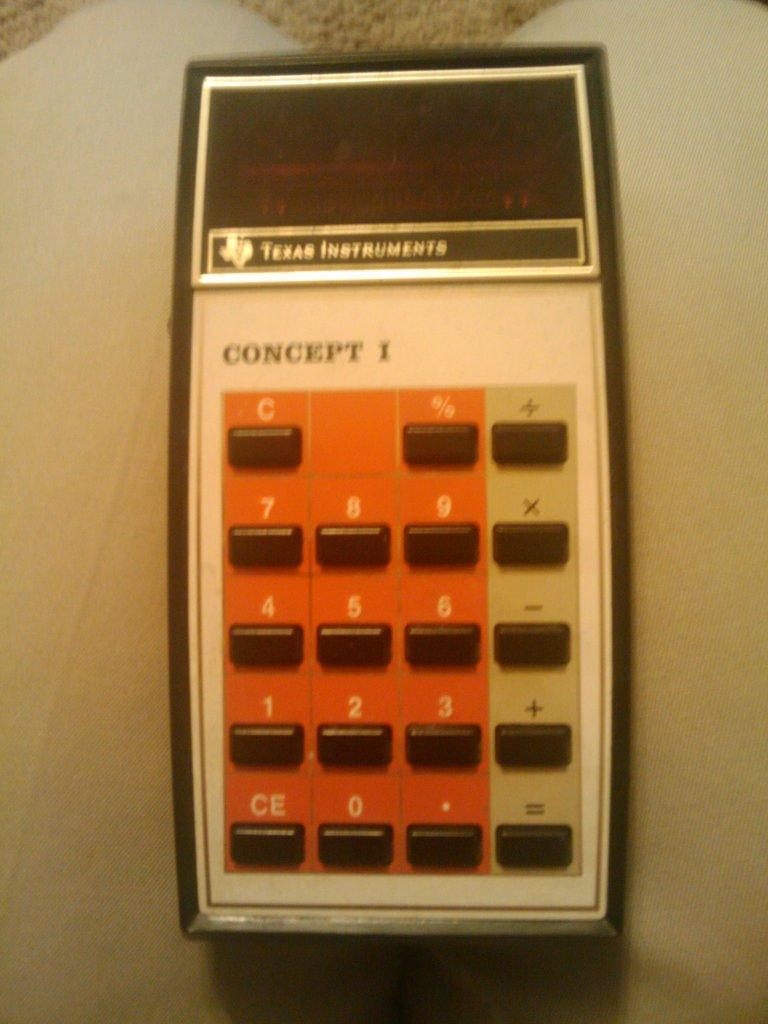What device is visible in the image? There is a calculator in the image. What features does the calculator have? The calculator has buttons and a display. Where is the calculator located in the image? The calculator is placed on a table. What is the color of the table? The table is white in color. Can you see a snail crawling on the calculator in the image? No, there is no snail present in the image. Is there a book lying next to the calculator in the image? No, there is no book visible in the image. 